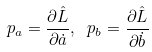<formula> <loc_0><loc_0><loc_500><loc_500>p _ { a } = \frac { \partial \hat { L } } { \partial \dot { a } } , \ p _ { b } = \frac { \partial \hat { L } } { \partial \dot { b } }</formula> 